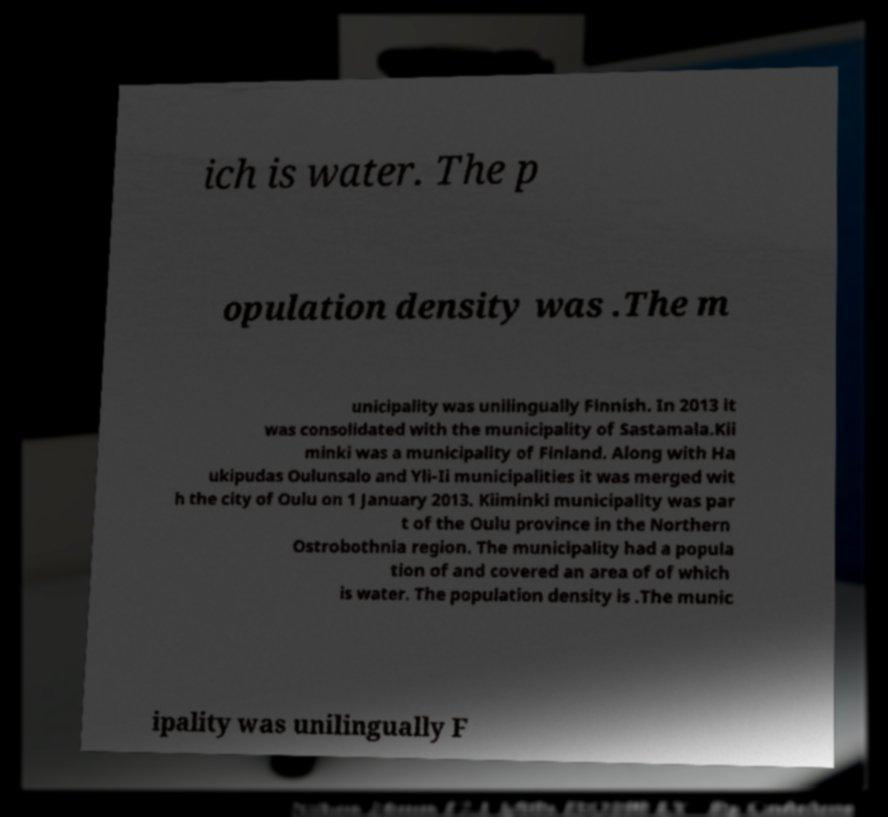I need the written content from this picture converted into text. Can you do that? ich is water. The p opulation density was .The m unicipality was unilingually Finnish. In 2013 it was consolidated with the municipality of Sastamala.Kii minki was a municipality of Finland. Along with Ha ukipudas Oulunsalo and Yli-Ii municipalities it was merged wit h the city of Oulu on 1 January 2013. Kiiminki municipality was par t of the Oulu province in the Northern Ostrobothnia region. The municipality had a popula tion of and covered an area of of which is water. The population density is .The munic ipality was unilingually F 